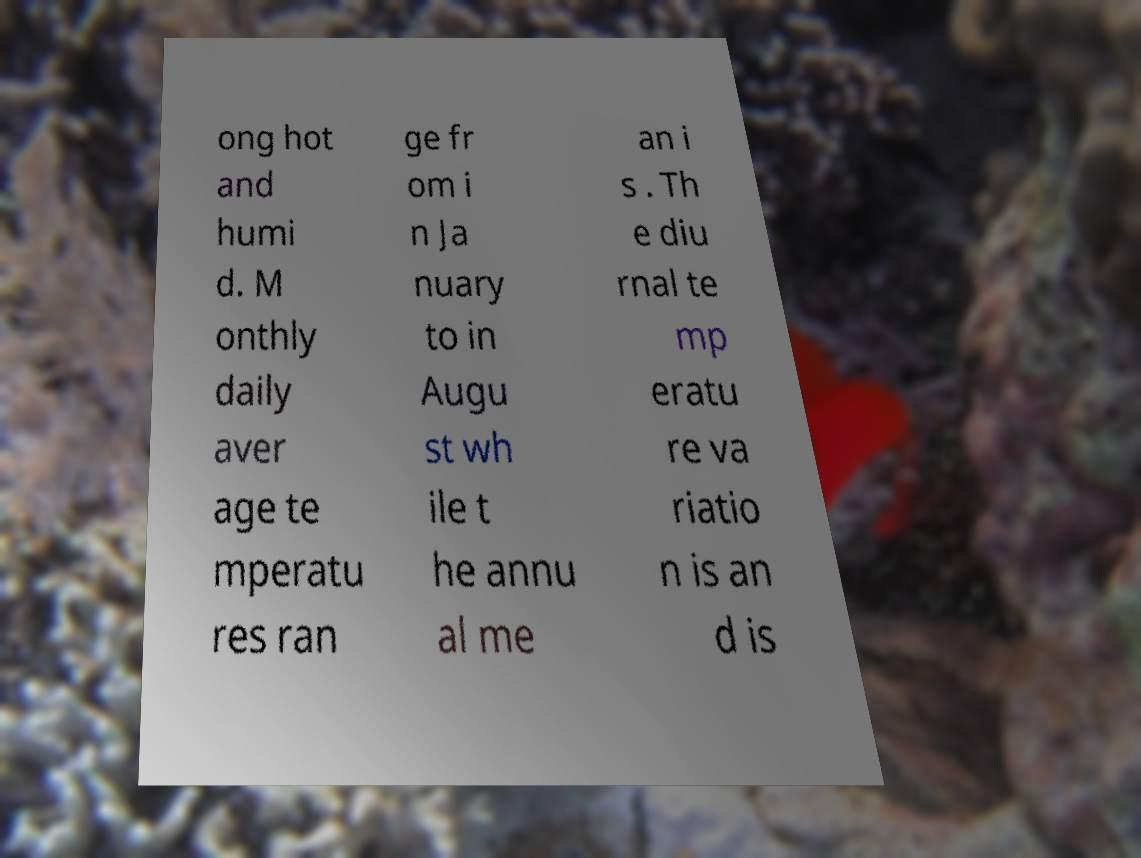Please identify and transcribe the text found in this image. ong hot and humi d. M onthly daily aver age te mperatu res ran ge fr om i n Ja nuary to in Augu st wh ile t he annu al me an i s . Th e diu rnal te mp eratu re va riatio n is an d is 